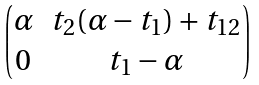<formula> <loc_0><loc_0><loc_500><loc_500>\begin{pmatrix} \alpha & t _ { 2 } ( \alpha - t _ { 1 } ) + t _ { 1 2 } \\ 0 & t _ { 1 } - \alpha \end{pmatrix}</formula> 